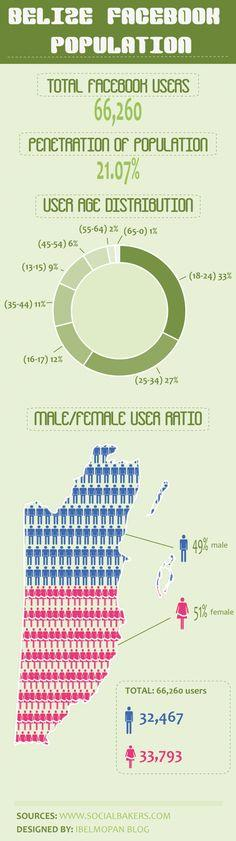Mention a couple of crucial points in this snapshot. Female users and male users differ by percentage, with a difference of 2%. There is a difference between female users and male users. The difference between users with the age group of 18-24 and 25-34 is 6%. 